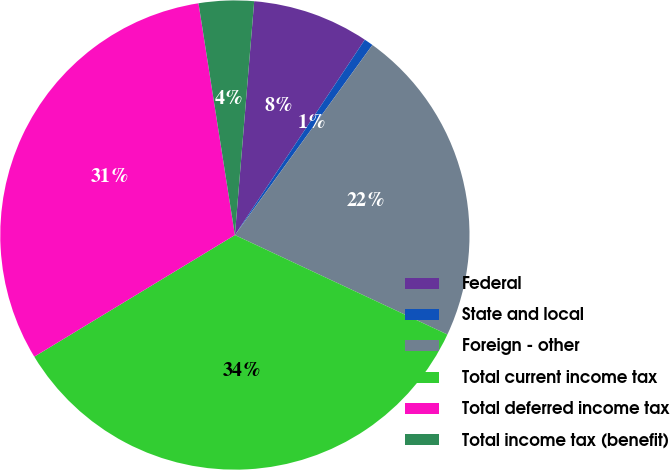Convert chart to OTSL. <chart><loc_0><loc_0><loc_500><loc_500><pie_chart><fcel>Federal<fcel>State and local<fcel>Foreign - other<fcel>Total current income tax<fcel>Total deferred income tax<fcel>Total income tax (benefit)<nl><fcel>8.03%<fcel>0.63%<fcel>22.0%<fcel>34.36%<fcel>31.2%<fcel>3.79%<nl></chart> 